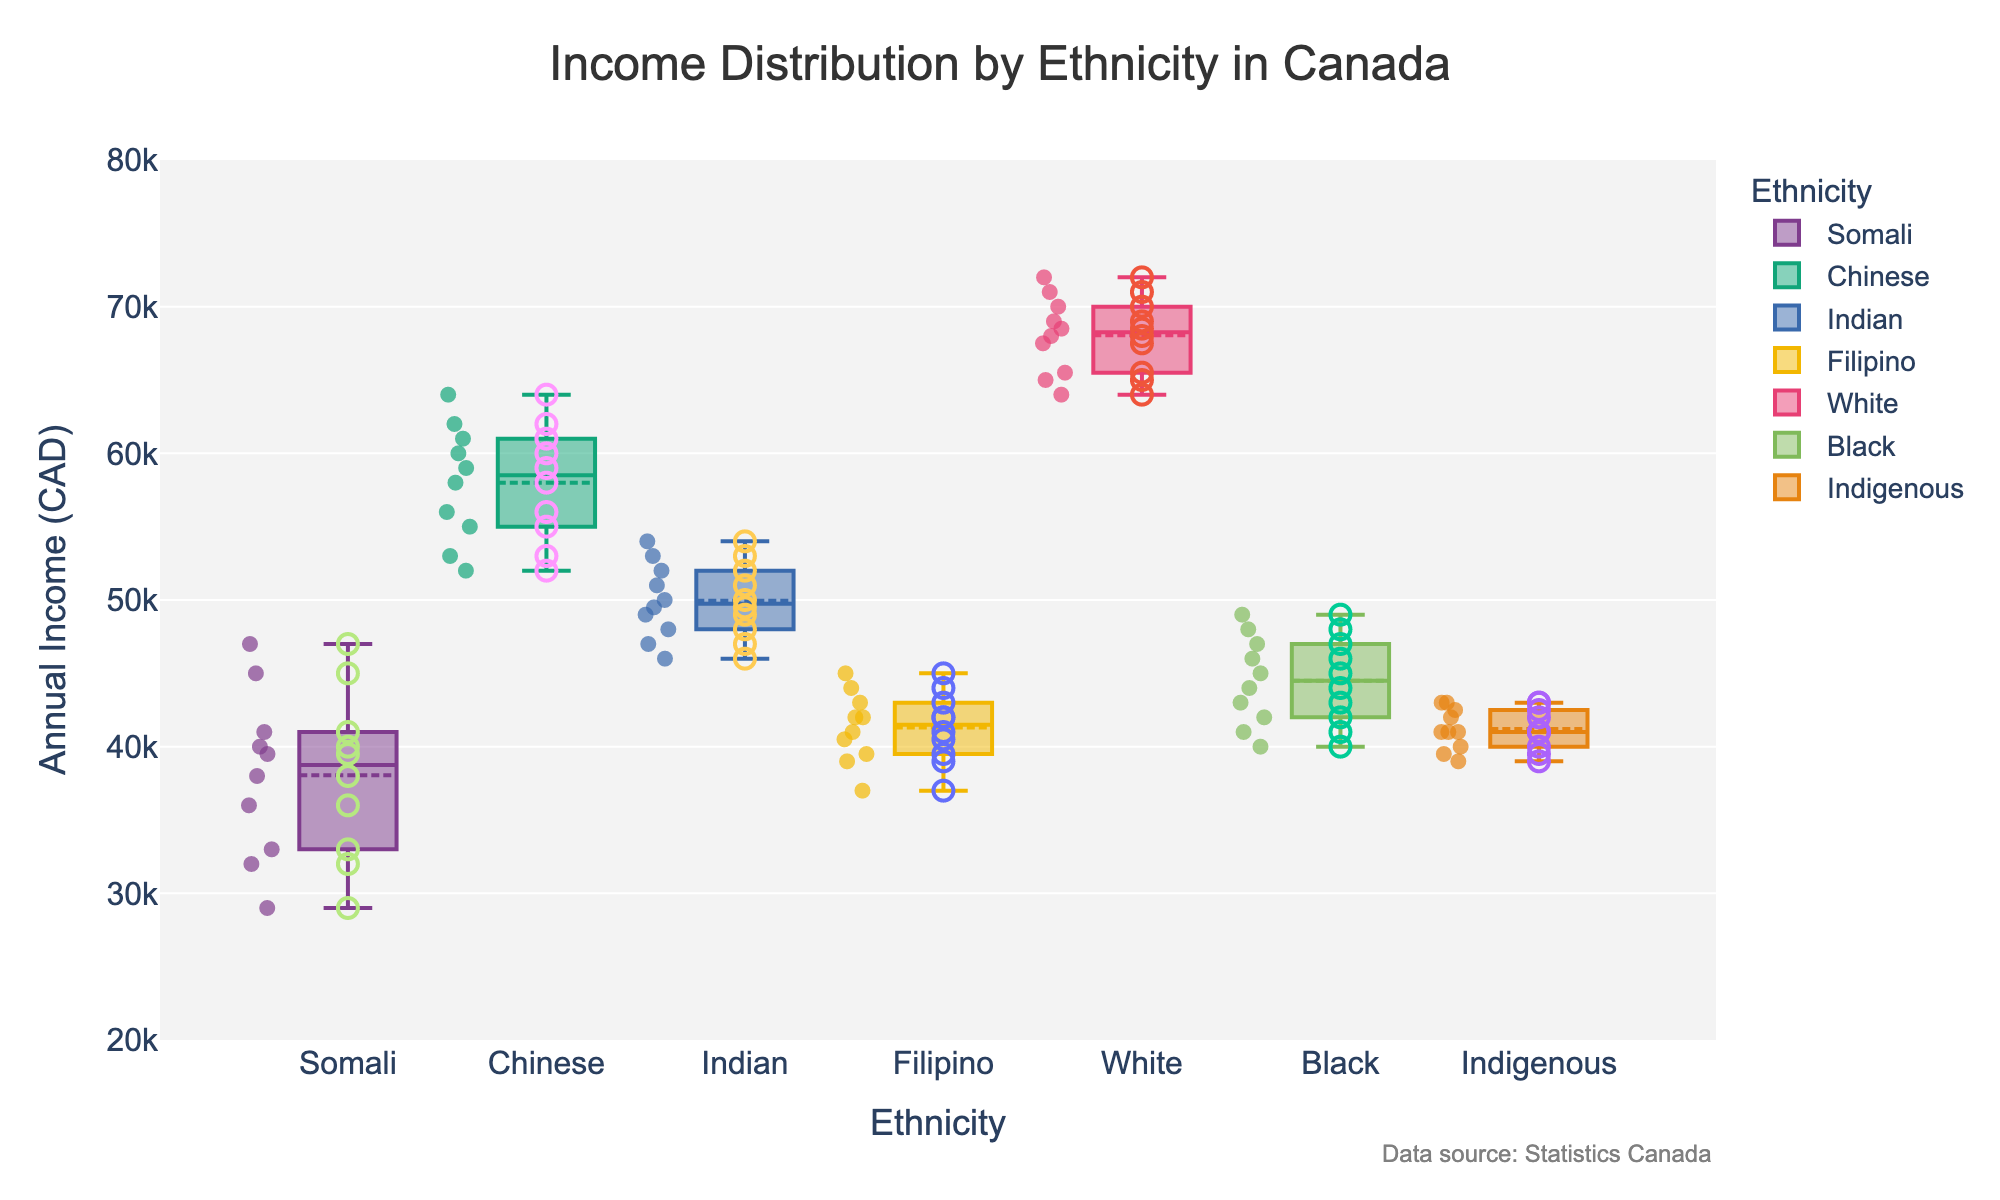What is the median income for the Somali community? The box plot represents the quartiles of the distribution. The median is denoted by the line inside the box representing the Somali community. Observing the plot, this line is at approximately 37,000 CAD.
Answer: 37,000 CAD Which community has the highest median income? Look for the median line inside the boxes of each community's box plot. The median line for the White community is the highest among all ethnicities which is around 68,000 CAD.
Answer: White community What is the range of incomes for the Chinese community? The range is calculated by subtracting the minimum value from the maximum value observed in the box plot and scatter points. For the Chinese community, the minimum scatter point is around 52,000 CAD and the maximum scatter point is around 64,000 CAD. Therefore, the range is 64,000 CAD - 52,000 CAD = 12,000 CAD.
Answer: 12,000 CAD How do the incomes for the Filipino community compare to those of the Indigenous community? To compare, examine the box plots and scatter points of both communities. The Filipino community shows most incomes around the lower 40,000 CAD, while the Indigenous community has a slightly larger distribution but similar median values.
Answer: Similar median, wider distribution for Indigenous Which community has the widest income distribution spread? The spread for each community can be observed from the interquartile range (IQR; the box length) and scatter points. The White community has the widest spread with incomes ranging from about 64,000 CAD to 72,000 CAD.
Answer: White community Are there any outliers in the data? Outliers in a box plot are typically represented as individual points lying far outside the range of whiskers. Observing the scatter points, the data does not show significant outliers for any community.
Answer: No significant outliers Which community has the most consistent income distribution? Consistent income distribution can be inferred from the smallest IQR and tightly clustered scatter points. The Chinese community shows a highly consistent pattern with tight clustering around the median.
Answer: Chinese community What is the typical income range for the Black community? From the box plot and scatter points, observe the lower and upper quartiles for the Black community. The interquartile range captures most incomes from about 40,000 CAD to 49,000 CAD.
Answer: 40,000 CAD to 49,000 CAD How does the income distribution of the Indian community compare to the Somali community? Comparing the box plots of both communities, the Indian community has higher incomes overall, with a median around 50,000 CAD compared to Somali's 37,000 CAD, and a more compact distribution.
Answer: Indian incomes higher, more compact distribution 